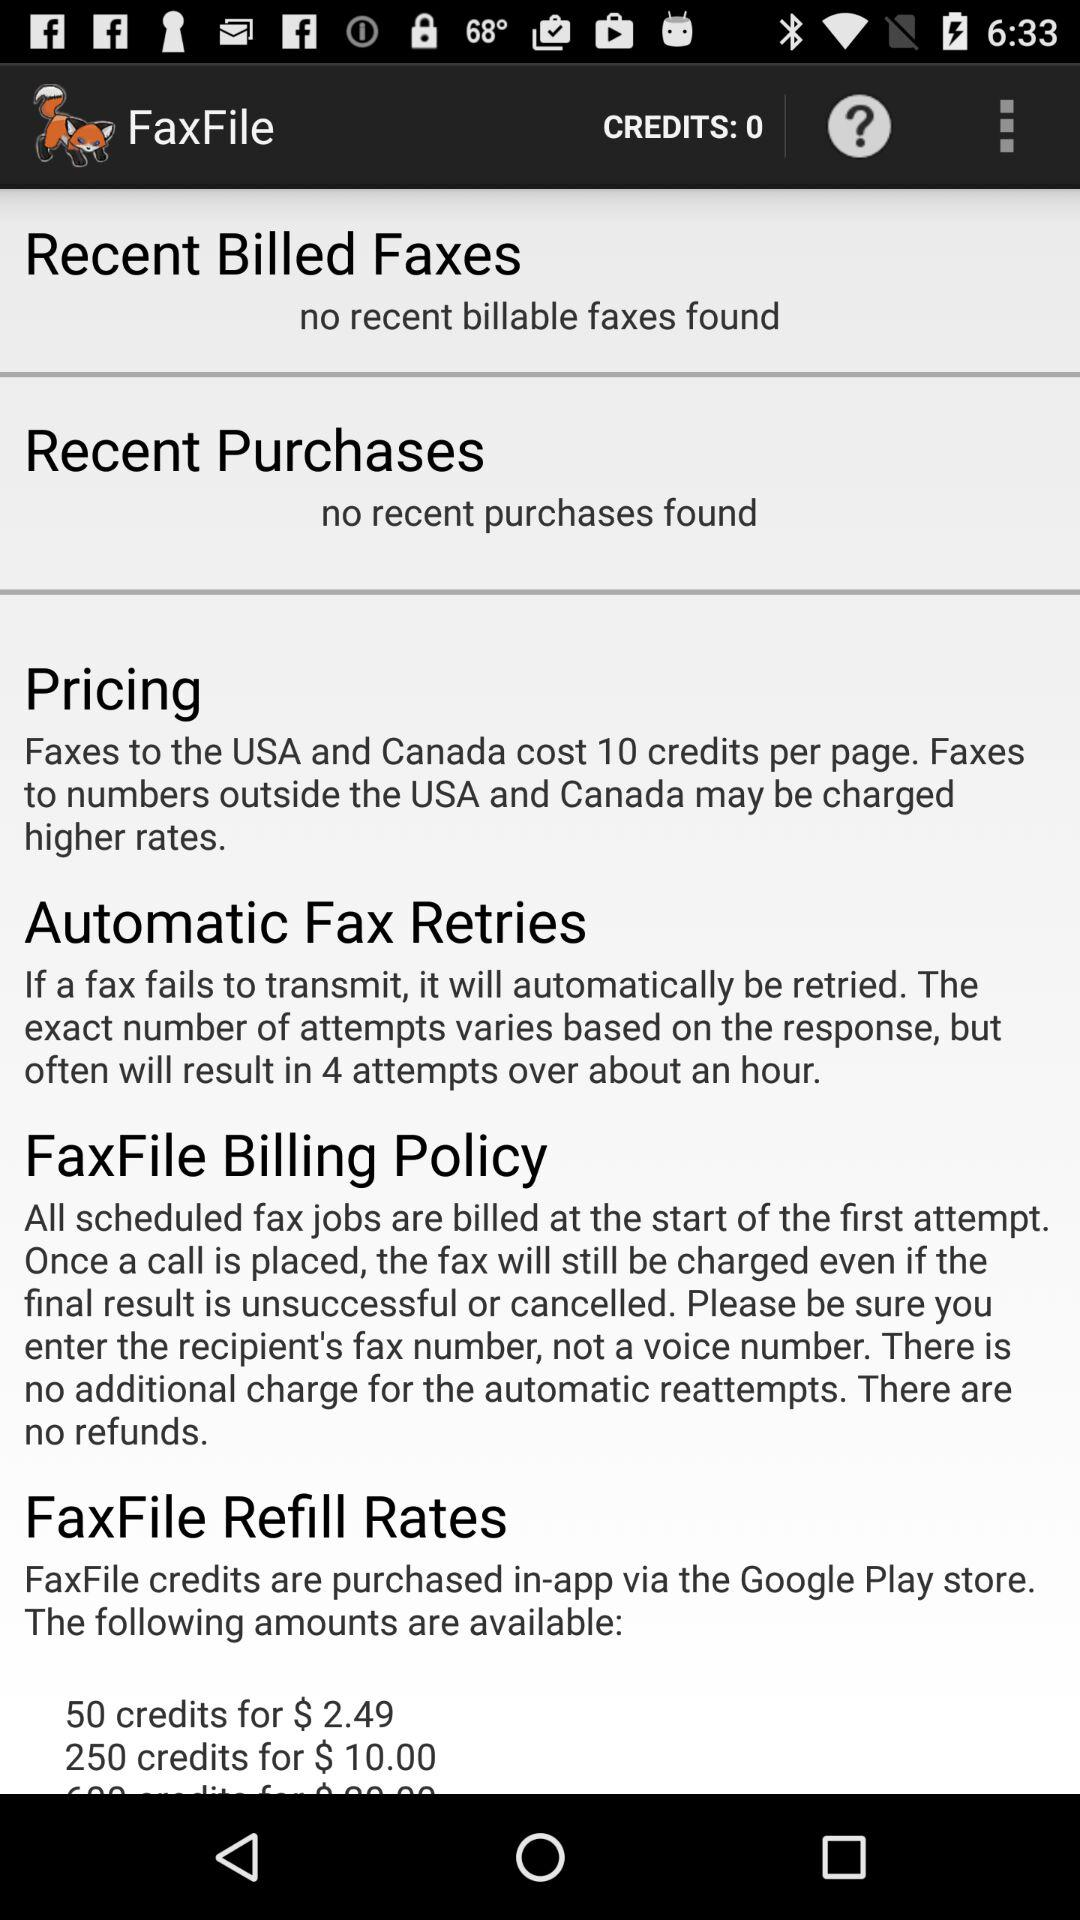What is the credit score? The credit score is 0. 